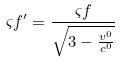<formula> <loc_0><loc_0><loc_500><loc_500>\varsigma f ^ { \prime } = \frac { \varsigma f } { \sqrt { 3 - \frac { v ^ { 0 } } { c ^ { 0 } } } }</formula> 